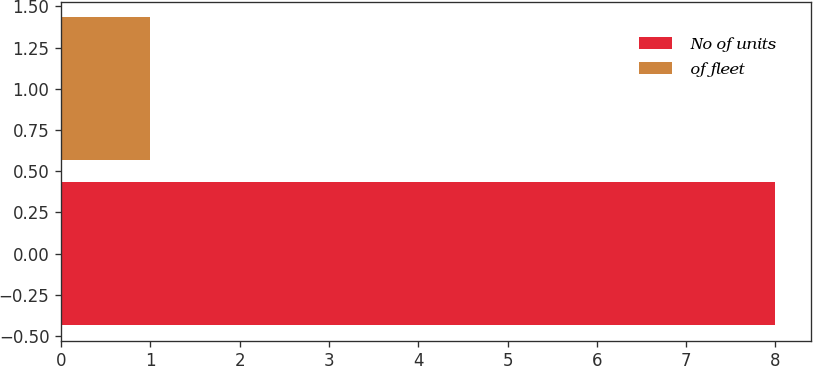Convert chart to OTSL. <chart><loc_0><loc_0><loc_500><loc_500><bar_chart><fcel>No of units<fcel>of fleet<nl><fcel>8<fcel>1<nl></chart> 